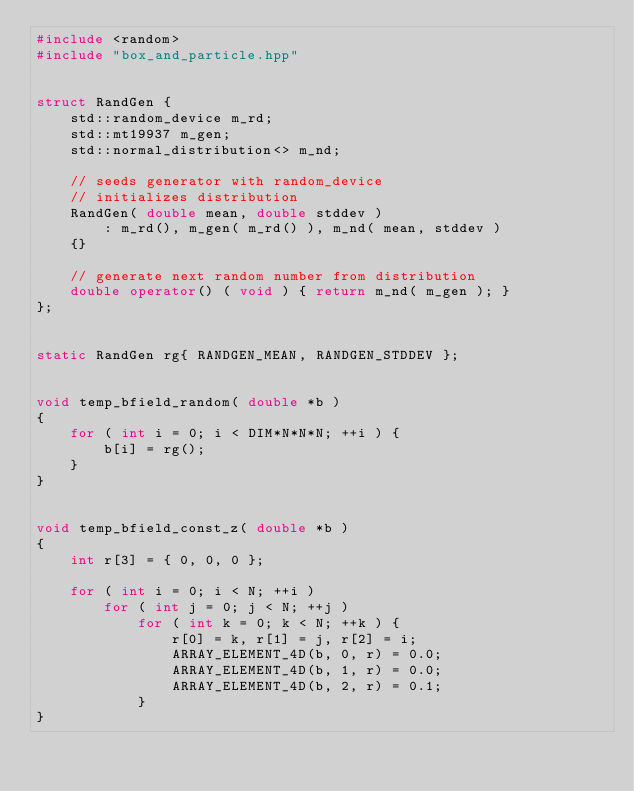<code> <loc_0><loc_0><loc_500><loc_500><_C++_>#include <random>
#include "box_and_particle.hpp"


struct RandGen {
    std::random_device m_rd;
    std::mt19937 m_gen;
    std::normal_distribution<> m_nd;

    // seeds generator with random_device
    // initializes distribution
    RandGen( double mean, double stddev )
        : m_rd(), m_gen( m_rd() ), m_nd( mean, stddev )
    {}

    // generate next random number from distribution
    double operator() ( void ) { return m_nd( m_gen ); }
};


static RandGen rg{ RANDGEN_MEAN, RANDGEN_STDDEV };


void temp_bfield_random( double *b )
{
    for ( int i = 0; i < DIM*N*N*N; ++i ) {
        b[i] = rg();
    }
}


void temp_bfield_const_z( double *b )
{
    int r[3] = { 0, 0, 0 };

    for ( int i = 0; i < N; ++i )
        for ( int j = 0; j < N; ++j )
            for ( int k = 0; k < N; ++k ) {
                r[0] = k, r[1] = j, r[2] = i;
                ARRAY_ELEMENT_4D(b, 0, r) = 0.0;
                ARRAY_ELEMENT_4D(b, 1, r) = 0.0;
                ARRAY_ELEMENT_4D(b, 2, r) = 0.1;
            }
}
</code> 